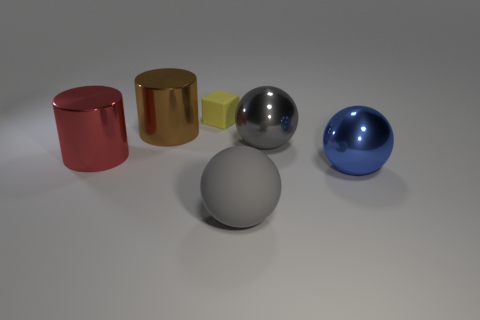There is a metallic ball that is the same color as the matte sphere; what size is it?
Ensure brevity in your answer.  Large. Does the matte ball have the same color as the metallic sphere that is to the left of the blue metal ball?
Provide a short and direct response. Yes. What number of big cylinders are to the left of the rubber object that is in front of the yellow rubber cube?
Keep it short and to the point. 2. The cylinder behind the cylinder in front of the big gray metallic ball is what color?
Give a very brief answer. Brown. There is a large object that is to the right of the red cylinder and on the left side of the cube; what material is it?
Offer a very short reply. Metal. Are there any other large objects of the same shape as the red object?
Your answer should be very brief. Yes. There is a shiny object on the left side of the brown cylinder; is it the same shape as the brown thing?
Your answer should be compact. Yes. What number of big cylinders are behind the red object and left of the brown object?
Provide a short and direct response. 0. There is a large gray thing in front of the big red cylinder; what shape is it?
Ensure brevity in your answer.  Sphere. What number of large balls are the same material as the red cylinder?
Ensure brevity in your answer.  2. 